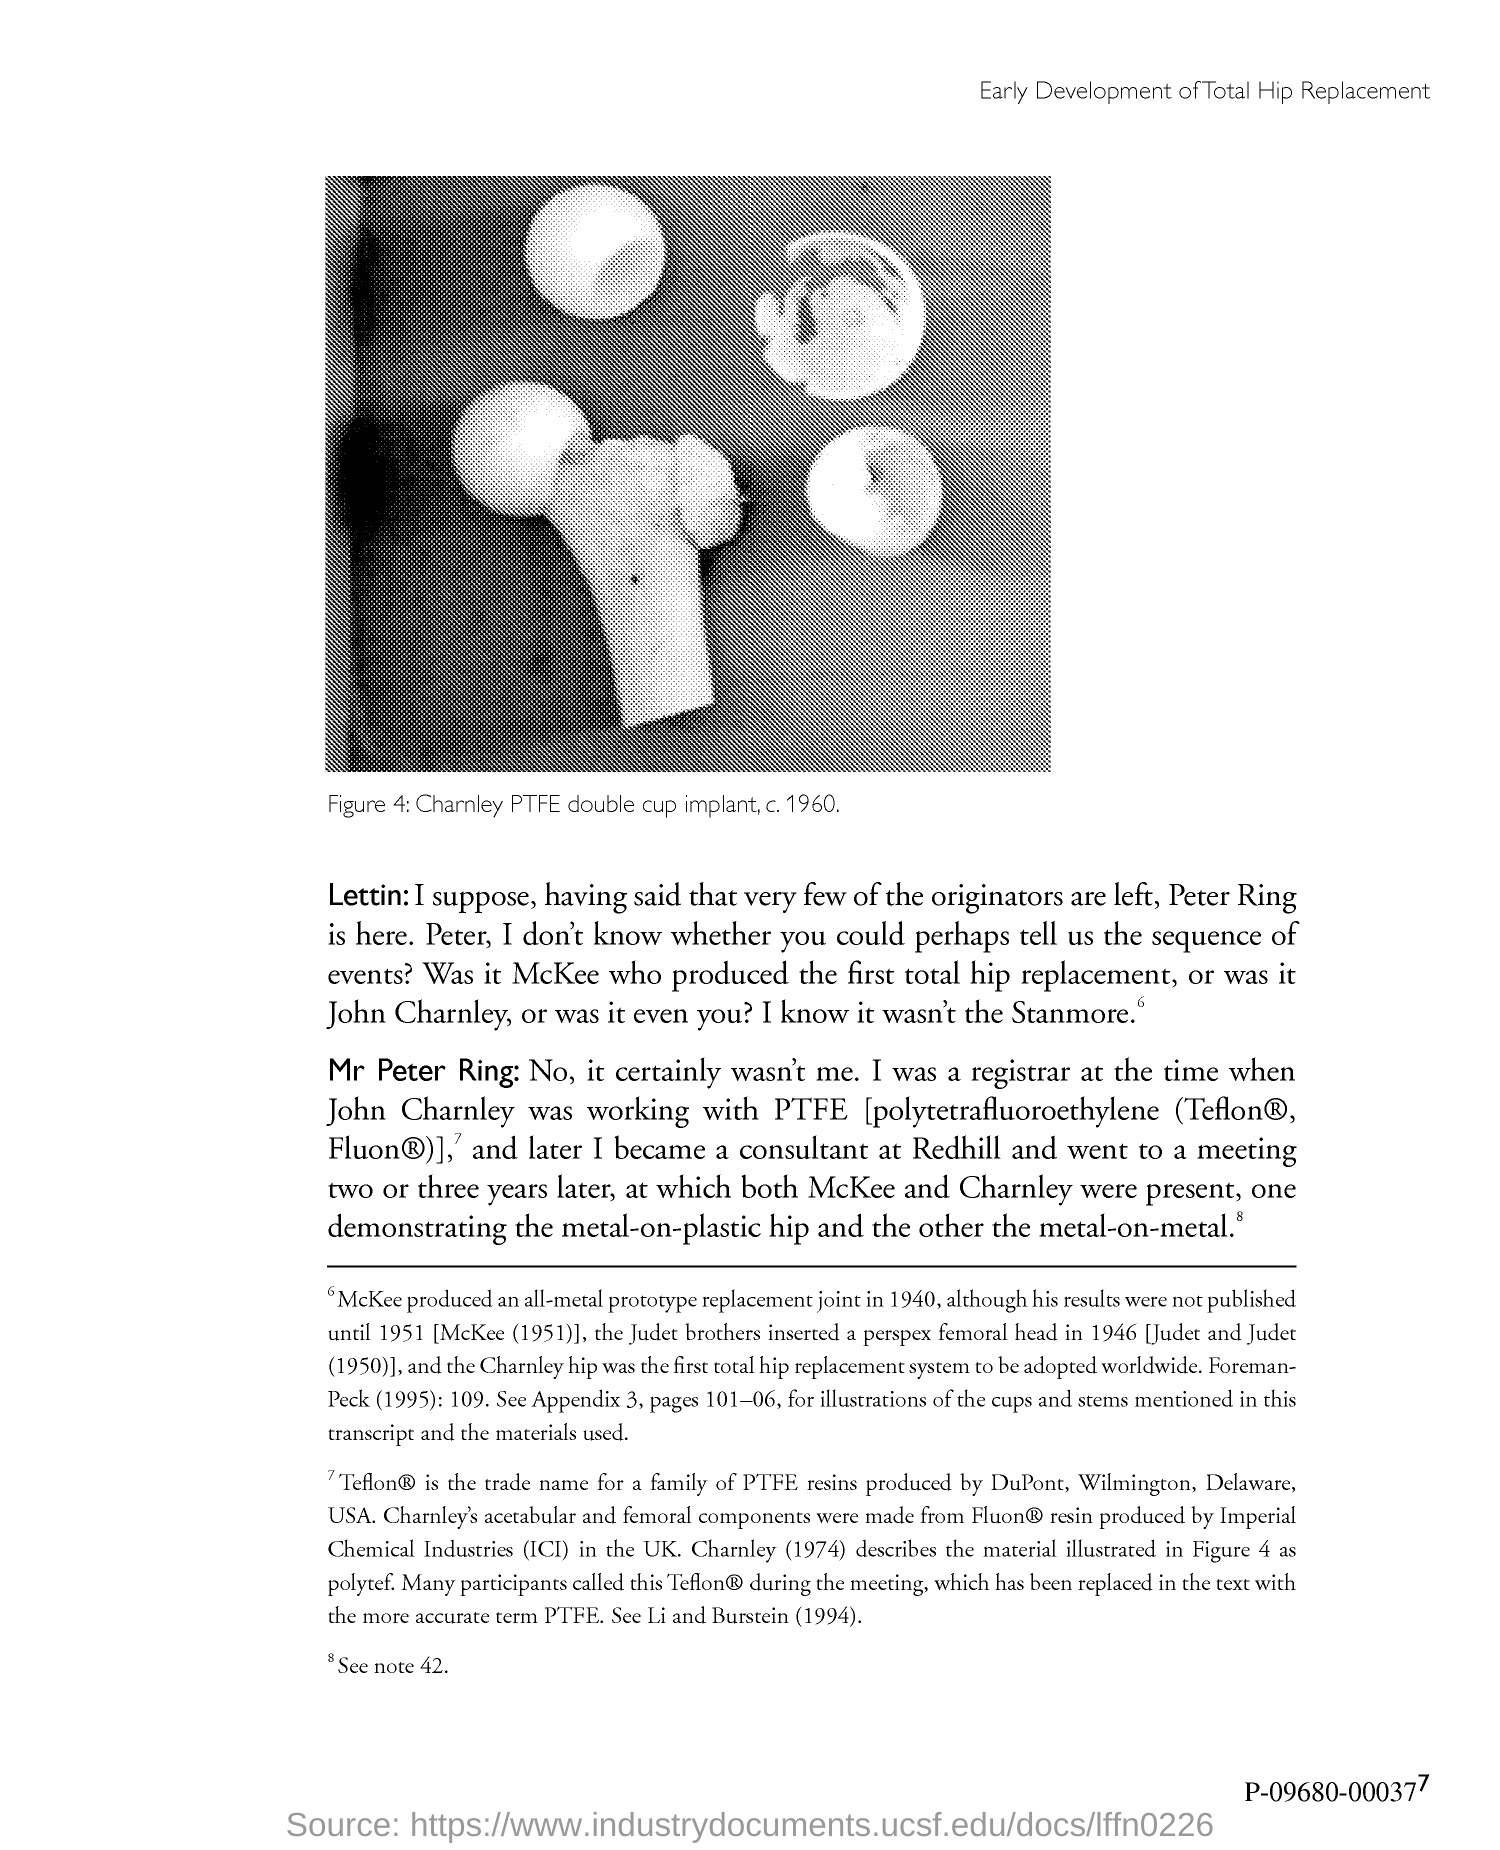When did McKee produce an all-metal prototype replacement joint?
Make the answer very short. 1940. 